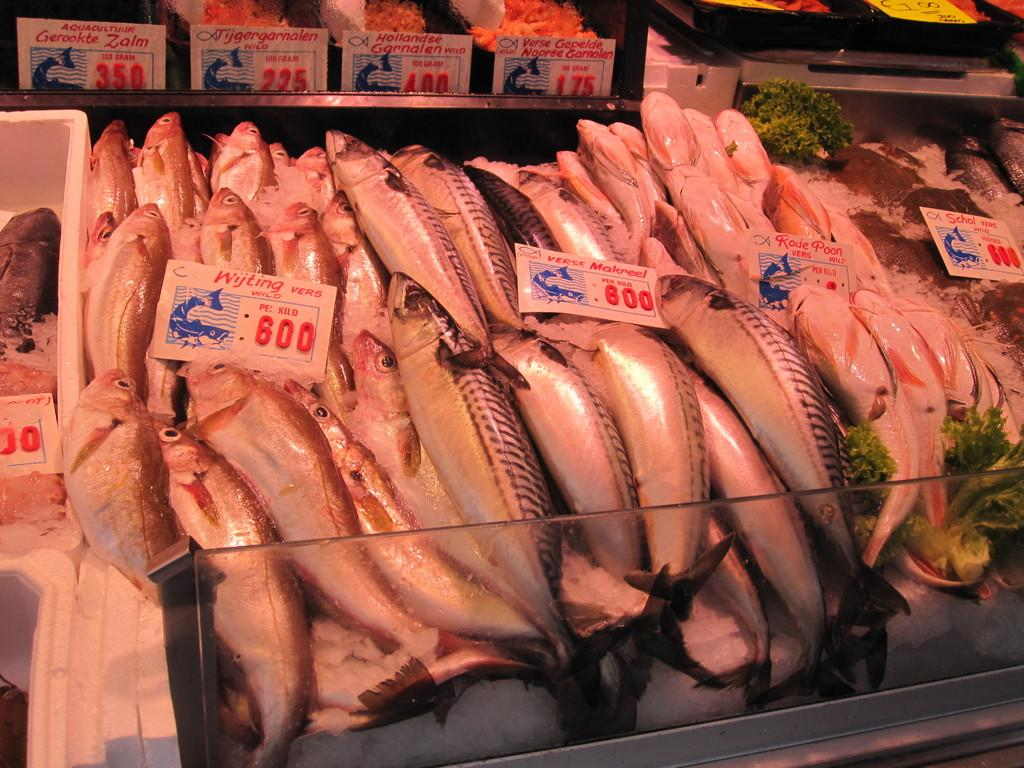What type of animals can be seen in the image? There are fishes in the image. What type of vegetable is present in the image? There is broccoli in the image. What can be used to determine the price of items in the image? Price tags are visible in the image. What is the arrangement of objects in the image? There are objects on platforms in the image. Where can the chalk be found in the image? There is no chalk present in the image. How many cherries are on the floor in the image? There are no cherries or floor visible in the image. 